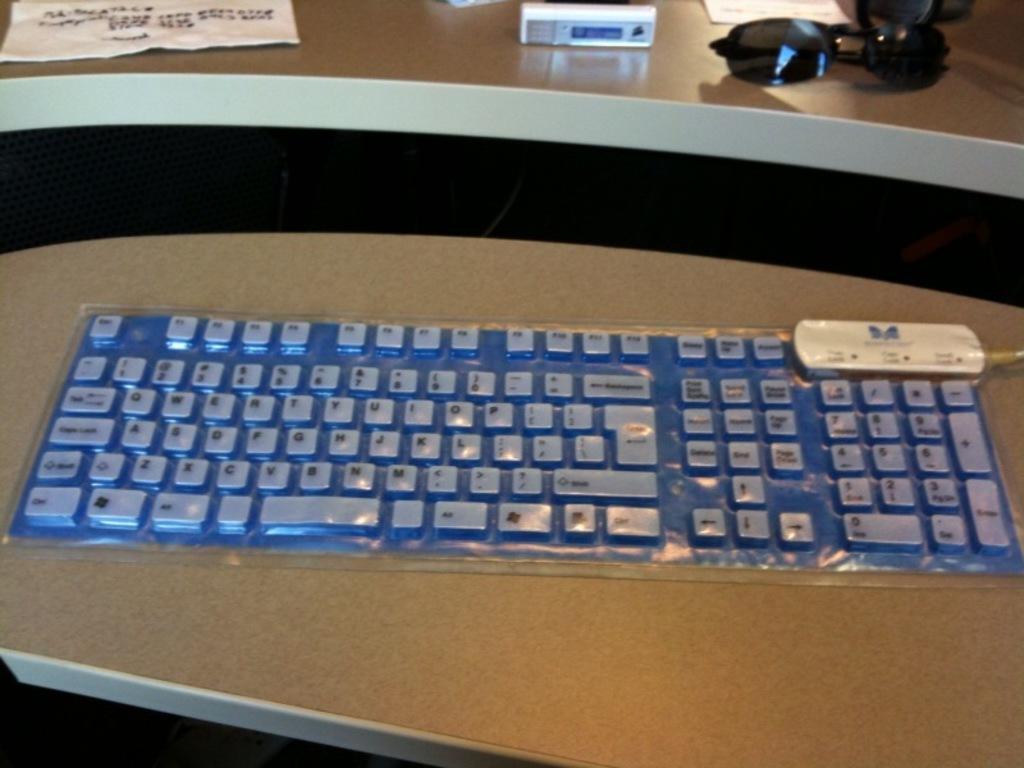How would you summarize this image in a sentence or two? This picture is mainly highlighted with a keyboard on the table. On the other table we can see a paper, device and black colour goggles. 